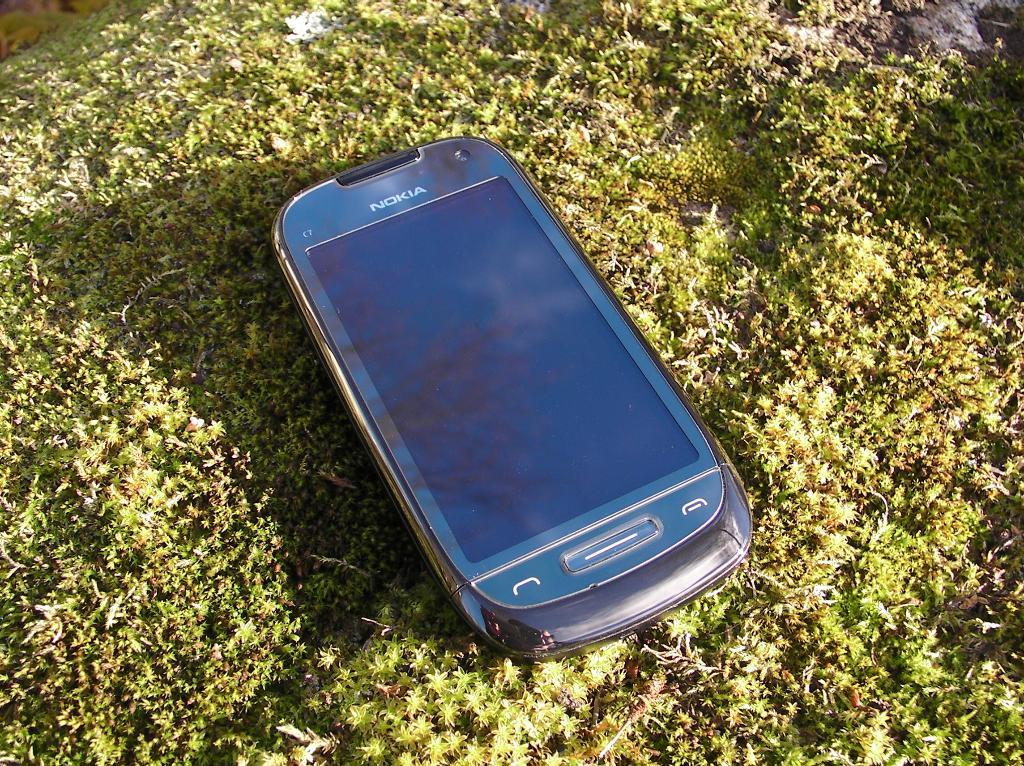Provide a one-sentence caption for the provided image. A Nokia cell phone that appears to be off is sitting on some moss. 